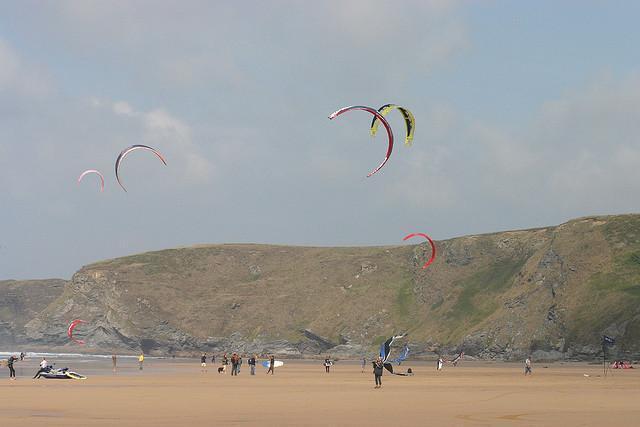How many red kites are there?
Give a very brief answer. 2. How many bikes are here?
Give a very brief answer. 0. How many people are on a motorcycle in the image?
Give a very brief answer. 0. 